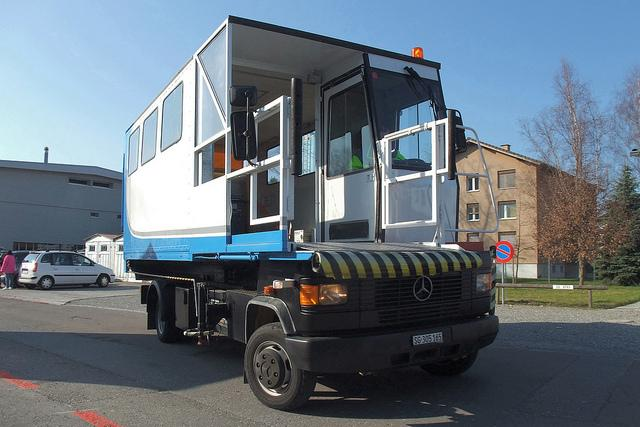What company made this vehicle? Please explain your reasoning. mercedes. The round logo on front of the vehicle is for the "mercedes" company. it's fairly universally known. 